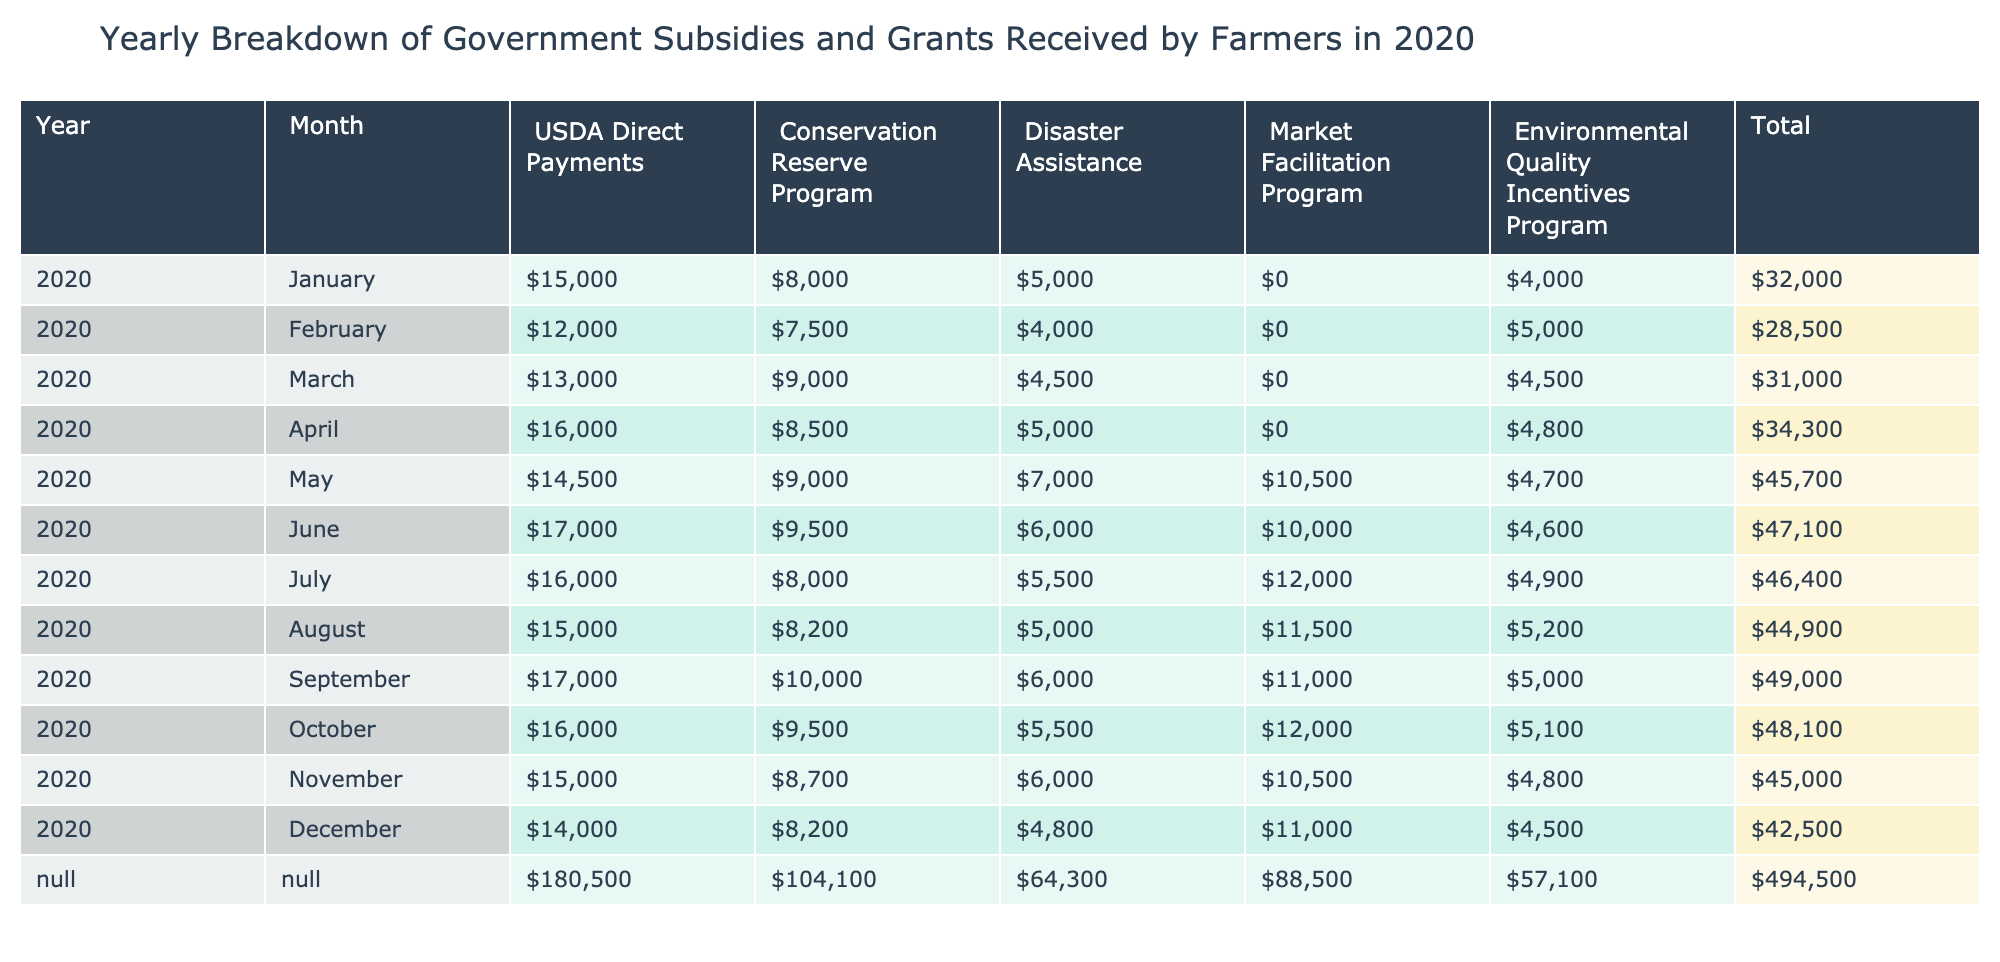What was the total amount received in USDA Direct Payments in May? In May, the table shows USDA Direct Payments as 14,500. Therefore, the total amount received in USDA Direct Payments in May is 14,500.
Answer: 14,500 What is the month with the highest amount received from the Market Facilitation Program? The highest amount received from the Market Facilitation Program was in May with 10,500. By looking through the values for each month, May had the maximum of 10,500.
Answer: May What was the total amount of Disaster Assistance received from January to March? To find the total, sum the amounts for Disaster Assistance for January (5,000), February (4,000), and March (4,500). The calculation is 5,000 + 4,000 + 4,500 = 13,500.
Answer: 13,500 Did the Environmental Quality Incentives Program receive more assistance in August than in September? By comparing the values for August (5,200) and September (5,000), we see that August has a higher amount. Thus the statement is true.
Answer: Yes What was the average amount received for USDA Direct Payments over the year? Calculate the total for USDA Direct Payments across all months: 15,000 + 12,000 + 13,000 + 16,000 + 14,500 + 17,000 + 16,000 + 15,000 + 17,000 + 16,000 + 15,000 + 14,000 = 178,500. Then divide by 12 (months), which is 178,500 / 12 = 14,875.
Answer: 14,875 What is the difference in total amounts received from the Conservation Reserve Program between March and October? The total for March is 9,000 and for October is 9,500. To find the difference, subtract March from October: 9,500 - 9,000 = 500.
Answer: 500 Which month had the lowest total funding when combining all programs? By adding totals for each month, we find that January had the lowest sum of payments at 5,000 (Disaster Assistance) + 15,000 (USDA Direct Payments) + 8,000 (Conservation Reserve Program) + 0 (Market Facilitation Program) + 4,000 (Environmental Quality Incentives Program) = 32,000. Comparing with other months shows January had the lowest.
Answer: January What is the total funding for the Environmental Quality Incentives Program for the entire year? Summing the values for Environmental Quality Incentives Program from each month: 4,000 + 5,000 + 4,500 + 4,800 + 4,700 + 4,600 + 4,900 + 5,200 + 5,000 + 5,100 + 4,800 + 4,500 = 54,100.
Answer: 54,100 In which month did the total funding surpass 50,000 for the first time? By analyzing the total monthly amounts, we see May is the first month exceeding 50,000 with a total of 56,700.
Answer: May 